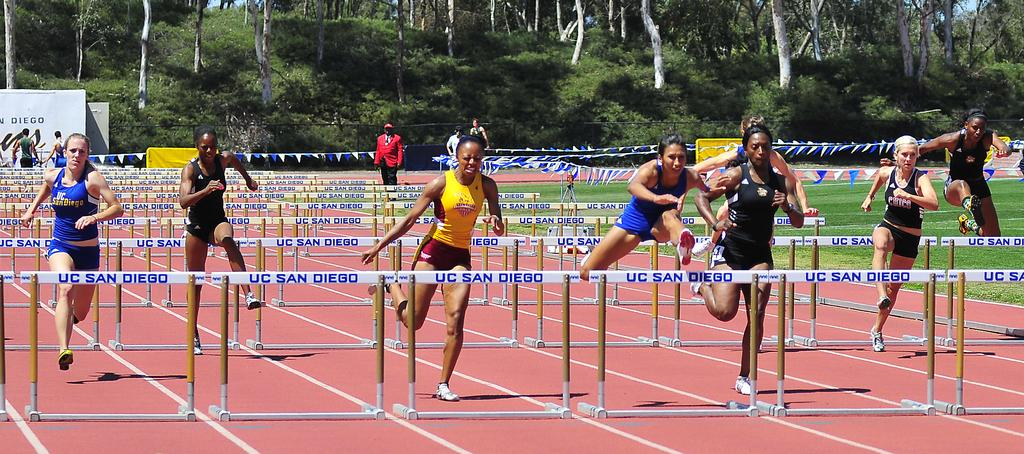Provide a one-sentence caption for the provided image. A group of track and field athletes compete at UC San Diego. 